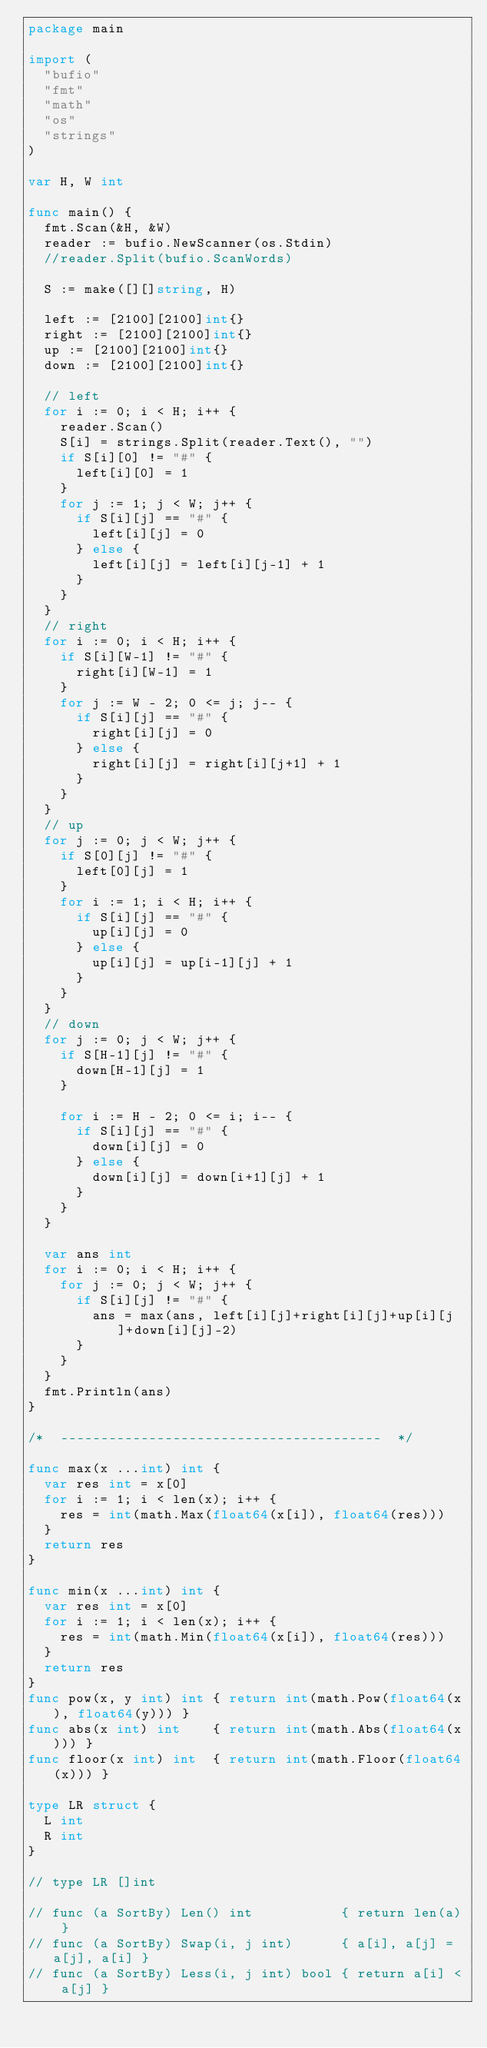Convert code to text. <code><loc_0><loc_0><loc_500><loc_500><_Go_>package main

import (
	"bufio"
	"fmt"
	"math"
	"os"
	"strings"
)

var H, W int

func main() {
	fmt.Scan(&H, &W)
	reader := bufio.NewScanner(os.Stdin)
	//reader.Split(bufio.ScanWords)

	S := make([][]string, H)

	left := [2100][2100]int{}
	right := [2100][2100]int{}
	up := [2100][2100]int{}
	down := [2100][2100]int{}

	// left
	for i := 0; i < H; i++ {
		reader.Scan()
		S[i] = strings.Split(reader.Text(), "")
		if S[i][0] != "#" {
			left[i][0] = 1
		}
		for j := 1; j < W; j++ {
			if S[i][j] == "#" {
				left[i][j] = 0
			} else {
				left[i][j] = left[i][j-1] + 1
			}
		}
	}
	// right
	for i := 0; i < H; i++ {
		if S[i][W-1] != "#" {
			right[i][W-1] = 1
		}
		for j := W - 2; 0 <= j; j-- {
			if S[i][j] == "#" {
				right[i][j] = 0
			} else {
				right[i][j] = right[i][j+1] + 1
			}
		}
	}
	// up
	for j := 0; j < W; j++ {
		if S[0][j] != "#" {
			left[0][j] = 1
		}
		for i := 1; i < H; i++ {
			if S[i][j] == "#" {
				up[i][j] = 0
			} else {
				up[i][j] = up[i-1][j] + 1
			}
		}
	}
	// down
	for j := 0; j < W; j++ {
		if S[H-1][j] != "#" {
			down[H-1][j] = 1
		}

		for i := H - 2; 0 <= i; i-- {
			if S[i][j] == "#" {
				down[i][j] = 0
			} else {
				down[i][j] = down[i+1][j] + 1
			}
		}
	}

	var ans int
	for i := 0; i < H; i++ {
		for j := 0; j < W; j++ {
			if S[i][j] != "#" {
				ans = max(ans, left[i][j]+right[i][j]+up[i][j]+down[i][j]-2)
			}
		}
	}
	fmt.Println(ans)
}

/*  ----------------------------------------  */

func max(x ...int) int {
	var res int = x[0]
	for i := 1; i < len(x); i++ {
		res = int(math.Max(float64(x[i]), float64(res)))
	}
	return res
}

func min(x ...int) int {
	var res int = x[0]
	for i := 1; i < len(x); i++ {
		res = int(math.Min(float64(x[i]), float64(res)))
	}
	return res
}
func pow(x, y int) int { return int(math.Pow(float64(x), float64(y))) }
func abs(x int) int    { return int(math.Abs(float64(x))) }
func floor(x int) int  { return int(math.Floor(float64(x))) }

type LR struct {
	L int
	R int
}

// type LR []int

// func (a SortBy) Len() int           { return len(a) }
// func (a SortBy) Swap(i, j int)      { a[i], a[j] = a[j], a[i] }
// func (a SortBy) Less(i, j int) bool { return a[i] < a[j] }
</code> 